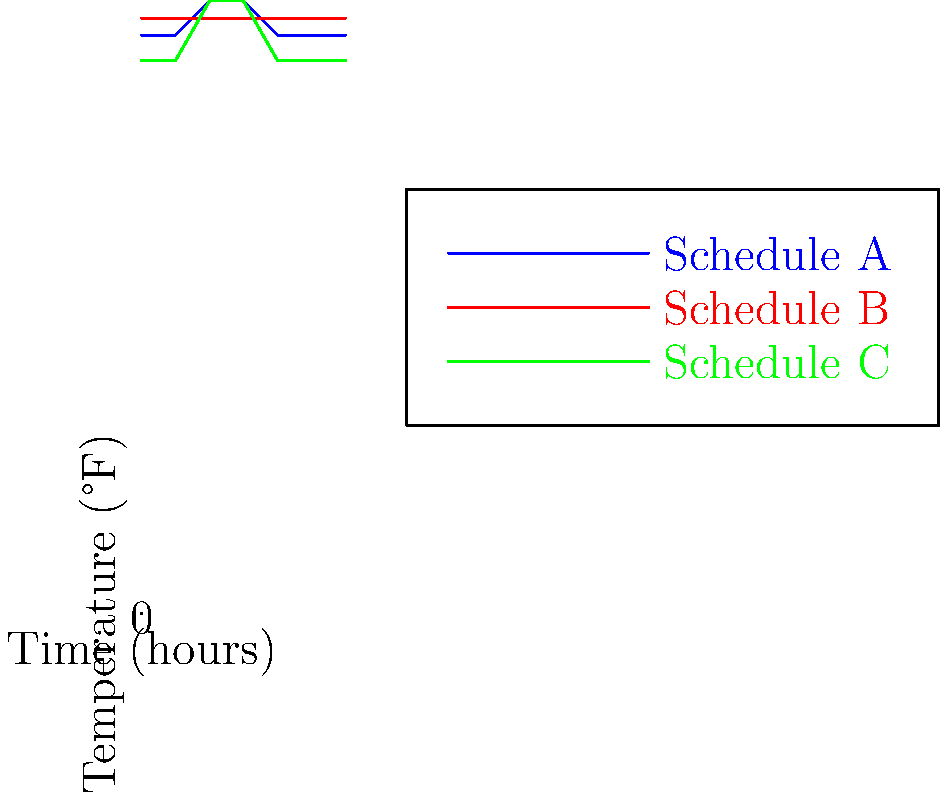Based on the temperature vs. time graphs for three different smart thermostat schedules (A, B, and C) over a 24-hour period, which schedule is likely to result in the greatest energy savings for heating during winter? To determine which schedule will result in the greatest energy savings for heating during winter, we need to analyze each schedule:

1. Schedule A (Blue):
   - Maintains 68°F from 8 PM to 8 AM
   - Increases to 72°F from 8 AM to 4 PM
   - Average temperature: 69.3°F

2. Schedule B (Red):
   - Maintains a constant 70°F throughout the day
   - Average temperature: 70°F

3. Schedule C (Green):
   - Maintains 65°F from 6 PM to 6 AM
   - Increases to 72°F from 6 AM to 6 PM
   - Average temperature: 68.5°F

In winter, lower temperatures generally result in less energy consumption for heating. The key factors to consider are:

1. Overall average temperature
2. Duration of lower temperature periods
3. Setback depth (how much the temperature is lowered)

Schedule C has the lowest average temperature (68.5°F) and the longest period of low temperature setting (12 hours at 65°F). This deep setback during nighttime hours, when occupants are likely sleeping, allows for significant energy savings.

Schedule A has a slightly higher average temperature (69.3°F) and a shorter low temperature period.

Schedule B maintains a constant temperature, which is generally less efficient than using setbacks.

Therefore, Schedule C is likely to result in the greatest energy savings for heating during winter.
Answer: Schedule C 